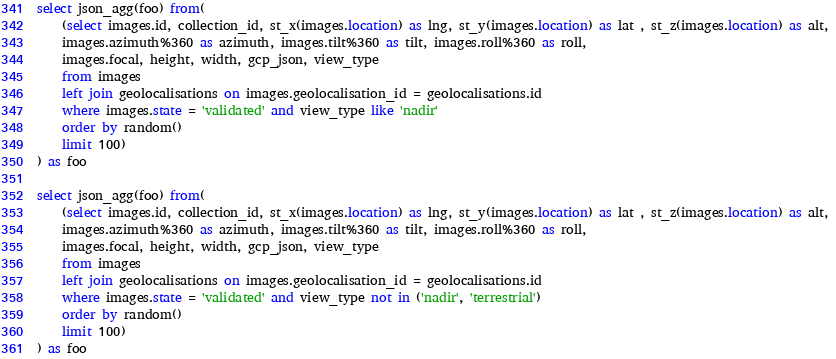Convert code to text. <code><loc_0><loc_0><loc_500><loc_500><_SQL_>select json_agg(foo) from(
	(select images.id, collection_id, st_x(images.location) as lng, st_y(images.location) as lat , st_z(images.location) as alt, 
	images.azimuth%360 as azimuth, images.tilt%360 as tilt, images.roll%360 as roll, 
	images.focal, height, width, gcp_json, view_type
	from images 
	left join geolocalisations on images.geolocalisation_id = geolocalisations.id
	where images.state = 'validated' and view_type like 'nadir'
	order by random()
	limit 100)
) as foo

select json_agg(foo) from(
	(select images.id, collection_id, st_x(images.location) as lng, st_y(images.location) as lat , st_z(images.location) as alt, 
	images.azimuth%360 as azimuth, images.tilt%360 as tilt, images.roll%360 as roll, 
	images.focal, height, width, gcp_json, view_type
	from images 
	left join geolocalisations on images.geolocalisation_id = geolocalisations.id
	where images.state = 'validated' and view_type not in ('nadir', 'terrestrial')
	order by random()
	limit 100)
) as foo
</code> 